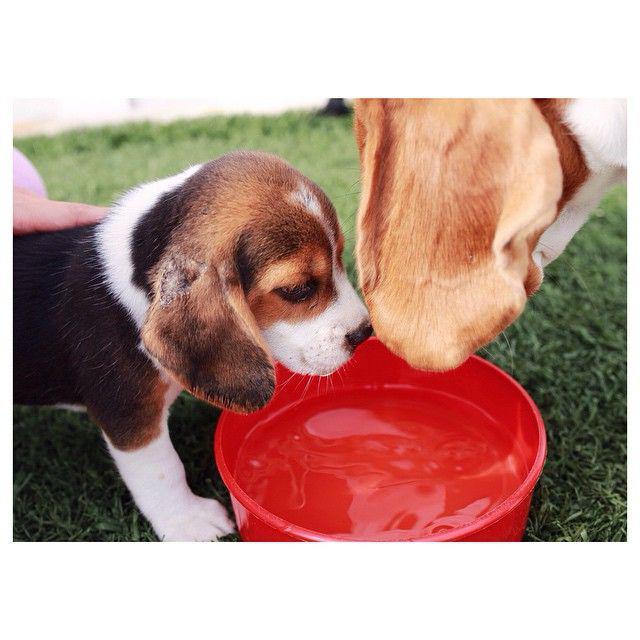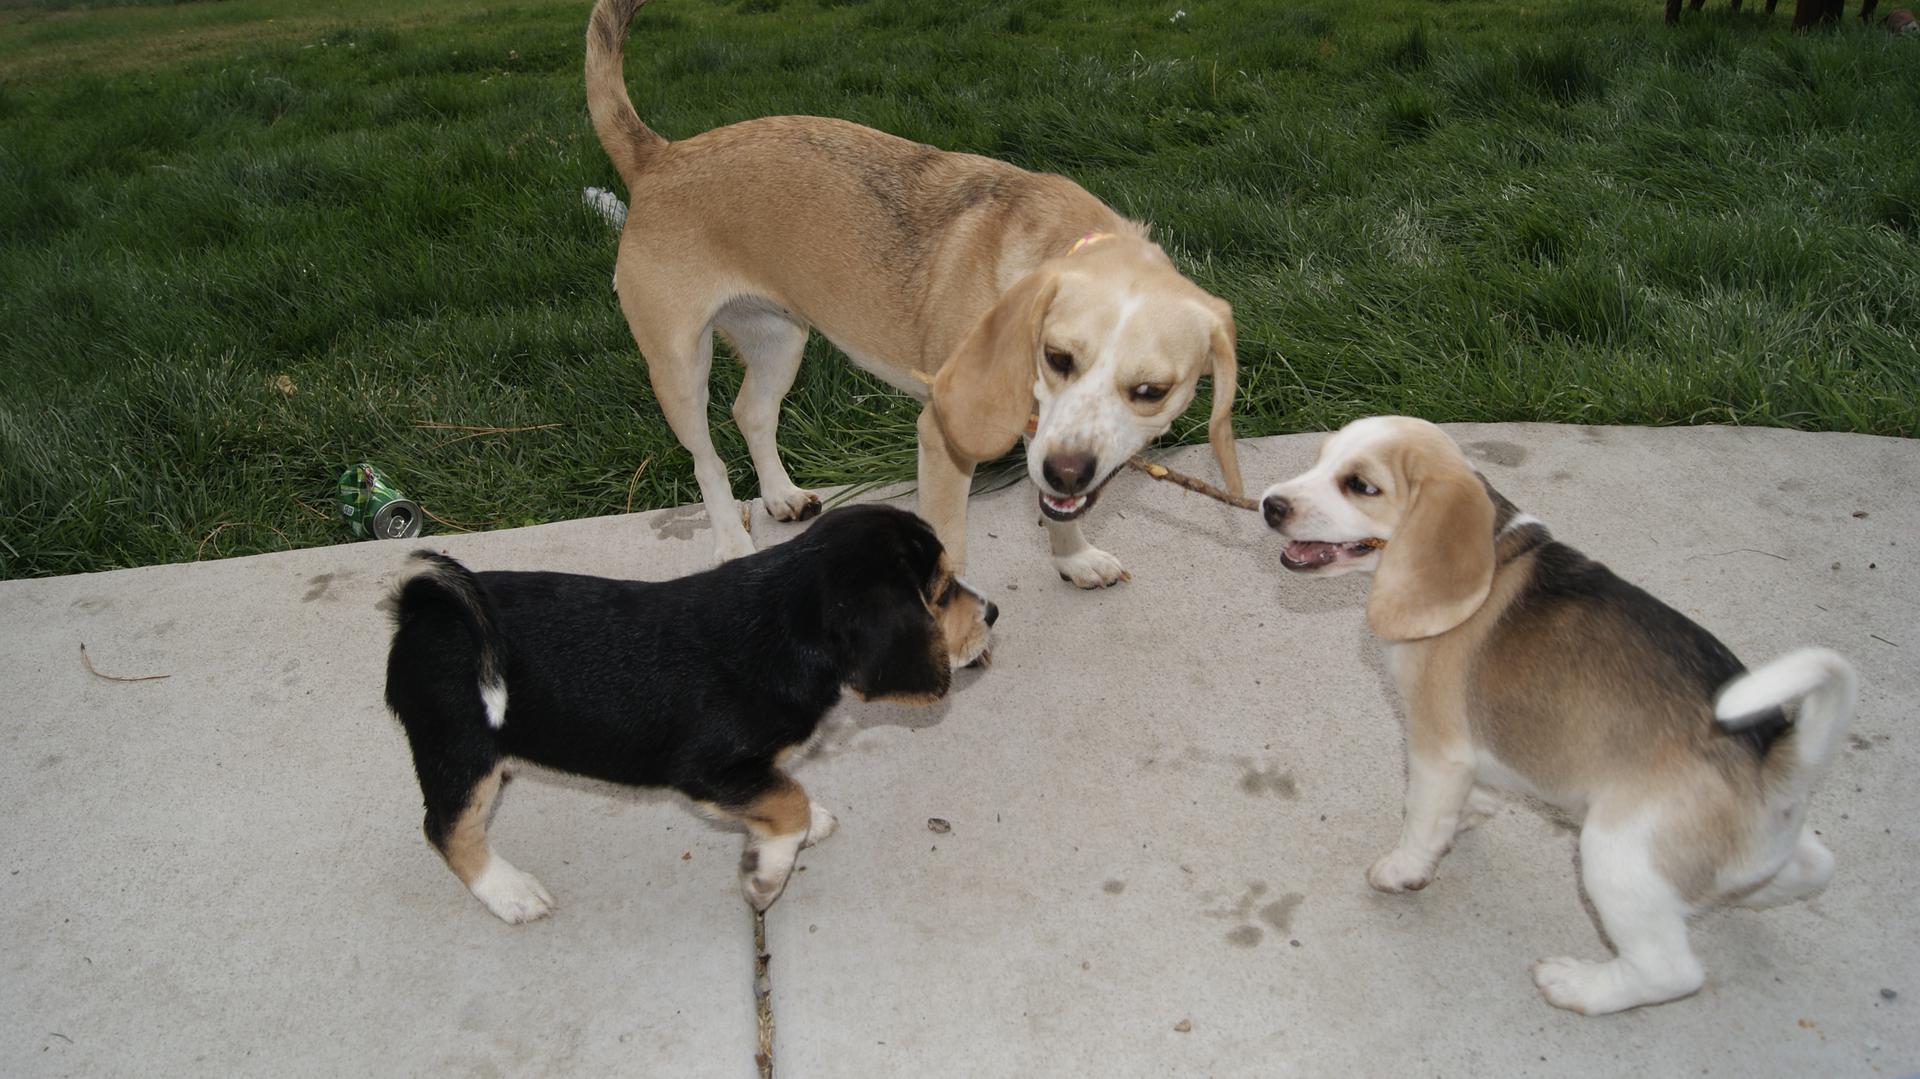The first image is the image on the left, the second image is the image on the right. Considering the images on both sides, is "There are no more than two dogs in the right image." valid? Answer yes or no. No. The first image is the image on the left, the second image is the image on the right. Given the left and right images, does the statement "One image shows a beagle outdoors on grass, with its mouth next to a plastic object that is at least partly bright red." hold true? Answer yes or no. Yes. 